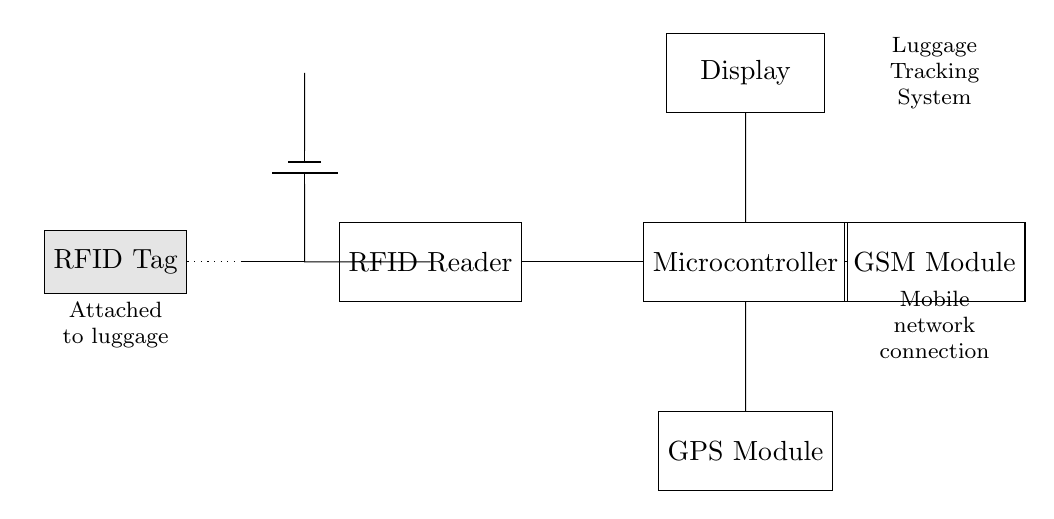What components are present in the circuit? The components visible in the circuit include an RFID Reader, Microcontroller, GPS Module, GSM Module, a Display, and an RFID Tag. Each component is represented as a distinct block in the diagram.
Answer: RFID Reader, Microcontroller, GPS Module, GSM Module, Display, RFID Tag What is the purpose of the RFID Tag? The RFID Tag is attached to the luggage and is used for identification and tracking purposes. This tag communicates wirelessly with the RFID Reader.
Answer: Identification and tracking How many modules are directly connected to the Microcontroller? The Microcontroller is connected to three modules: the RFID Reader, GPS Module, and GSM Module, which all link directly to it, allowing for integrated functionality.
Answer: Three What type of connection exists between the RFID Tag and RFID Reader? The connection is wireless as indicated by the dotted line, which shows that the RFID Tag communicates with the RFID Reader through radio frequency signals, rather than a physical connection.
Answer: Wireless What is the function of the GSM Module in this circuit? The GSM Module facilitates mobile network connection, allowing the system to send and receive data, providing real-time location tracking of the luggage, which is essential for high-end travel accessories.
Answer: Mobile network connection Where is the power supply located in the circuit? The power supply is indicated at the top left of the circuit, represented by a battery symbol, which is essential for powering the entire system including the RFID Reader and Microcontroller.
Answer: Top left What is displayed on the Display component of the circuit? The Display component is typically used to show relevant information about luggage location, status, or updates, allowing users to track their items effectively during travels.
Answer: Luggage location and updates 